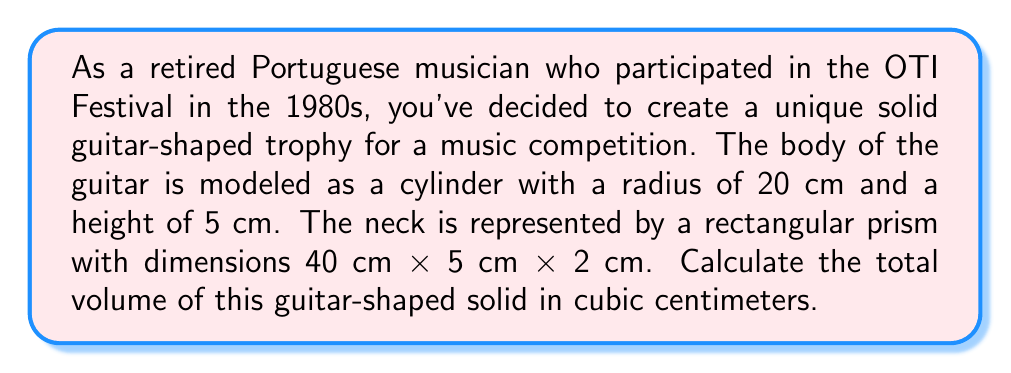Help me with this question. To calculate the total volume of the guitar-shaped solid, we need to find the volumes of its two components (the body and the neck) and add them together.

1. Volume of the guitar body (cylinder):
   The formula for the volume of a cylinder is $V_c = \pi r^2 h$, where $r$ is the radius and $h$ is the height.
   
   $$V_c = \pi (20\text{ cm})^2 (5\text{ cm}) = 2000\pi\text{ cm}^3$$

2. Volume of the guitar neck (rectangular prism):
   The formula for the volume of a rectangular prism is $V_p = l \times w \times h$, where $l$ is length, $w$ is width, and $h$ is height.
   
   $$V_p = 40\text{ cm} \times 5\text{ cm} \times 2\text{ cm} = 400\text{ cm}^3$$

3. Total volume:
   The total volume is the sum of the two components.
   
   $$V_{\text{total}} = V_c + V_p = 2000\pi\text{ cm}^3 + 400\text{ cm}^3$$

   $$V_{\text{total}} = (2000\pi + 400)\text{ cm}^3$$

   $$V_{\text{total}} \approx 6683.19\text{ cm}^3$$
Answer: The total volume of the guitar-shaped solid is approximately $6683.19\text{ cm}^3$. 